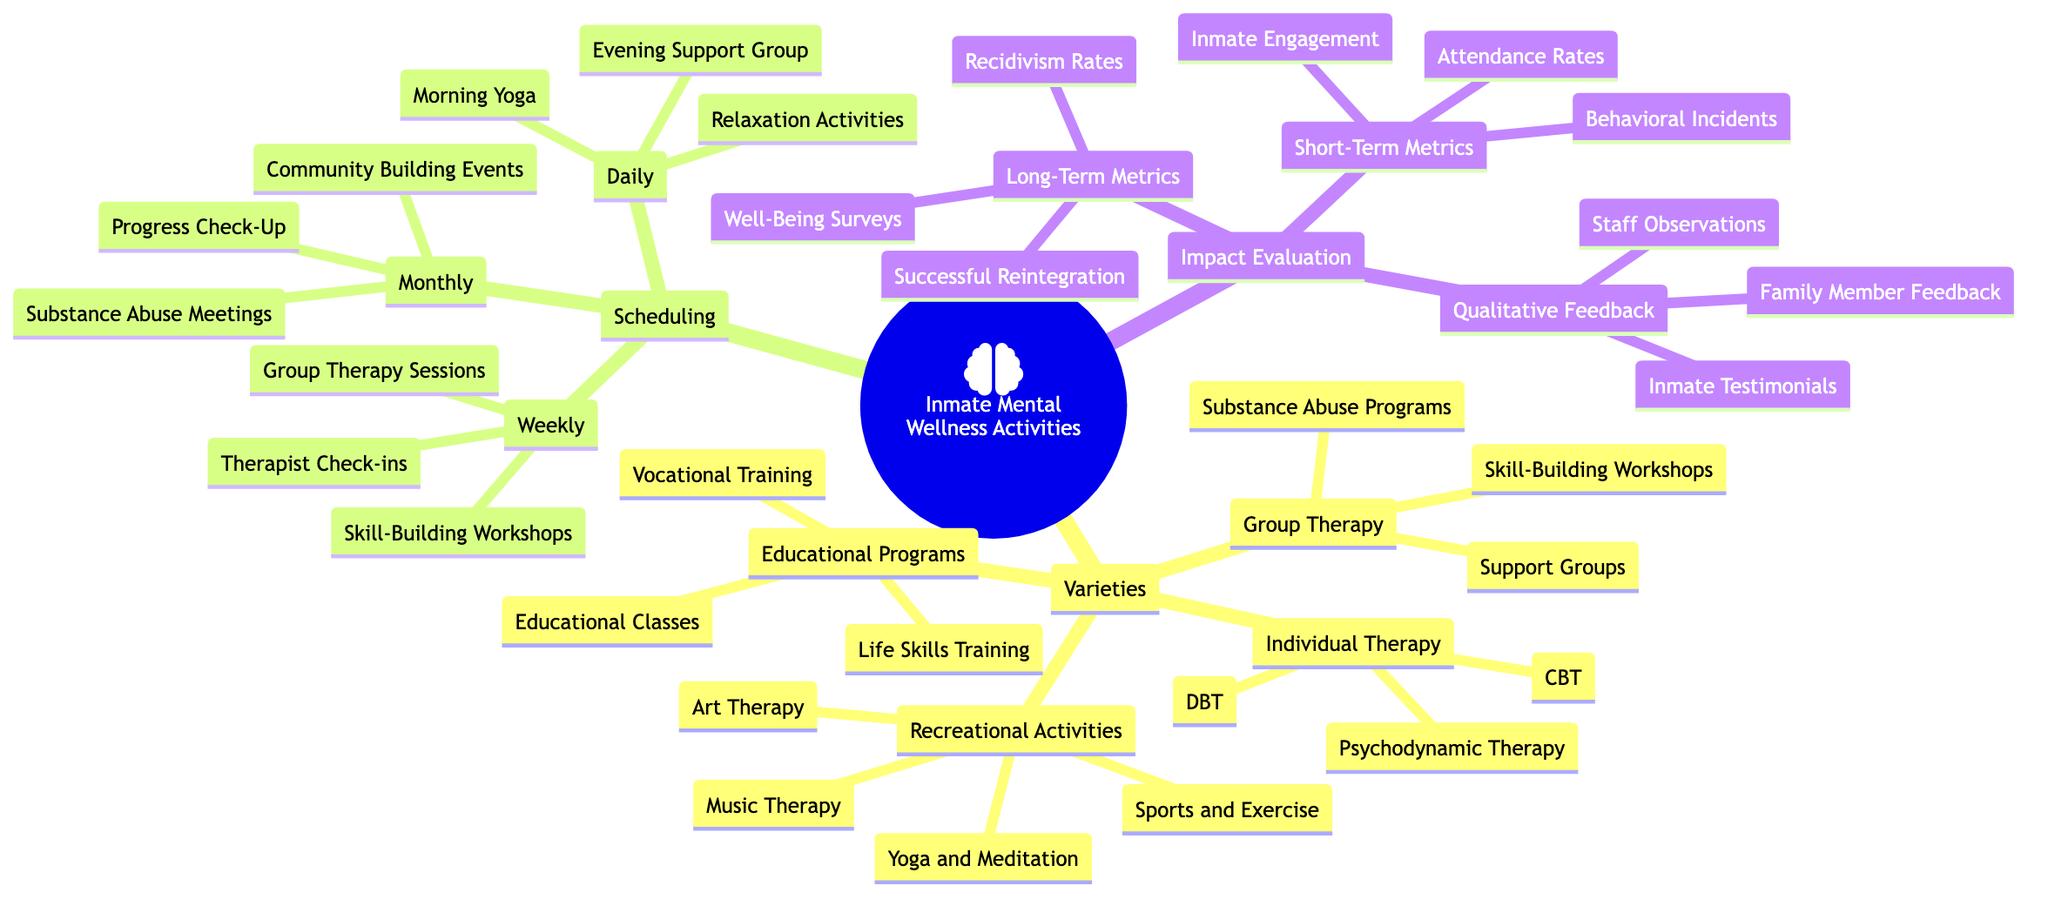What are the types of Individual Therapy listed? The diagram specifies three types under Individual Therapy: Cognitive Behavioral Therapy (CBT), Dialectical Behavior Therapy (DBT), and Psychodynamic Therapy.
Answer: Cognitive Behavioral Therapy, Dialectical Behavior Therapy, Psychodynamic Therapy How many categories are there under Scheduling? There are three main categories listed under Scheduling: Daily, Weekly, and Monthly.
Answer: 3 What is the purpose of the Substance Abuse Meetings listed in Monthly activities? The Substance Abuse Meetings, as indicated in the Monthly section, are likely intended to support inmates struggling with addiction, emphasizing their role in recovery and community support.
Answer: Support addiction recovery Which activity occurs daily at the prison? The diagram indicates that Morning Yoga occurs daily as one of the scheduled activities.
Answer: Morning Yoga What type of feedback is included in the Impact Evaluation section? There are three types of feedback included: Inmate Testimonials, Staff Observations, and Family Member Feedback, as part of the qualitative feedback evaluation.
Answer: Inmate Testimonials, Staff Observations, Family Member Feedback What two metrics are evaluated in the Long-Term Metrics? The long-term evaluation metrics listed are Recidivism Rates and Successful Reintegration Post-Release, focusing on the effectiveness of mental wellness activities over a longer period.
Answer: Recidivism Rates, Successful Reintegration Post-Release How many activities fall under Group Therapy? Under Group Therapy, there are three activities listed: Support Groups, Skill-Building Workshops, and Substance Abuse Programs.
Answer: 3 What is one recreational activity that promotes inmate mental wellness? Music Therapy is one of the recreational activities listed that promotes mental wellness among inmates.
Answer: Music Therapy Which activities are scheduled weekly? The diagram indicates that Therapist Check-ins, Group Therapy Sessions, and Skill-Building Workshops are scheduled weekly.
Answer: Therapist Check-ins, Group Therapy Sessions, Skill-Building Workshops 